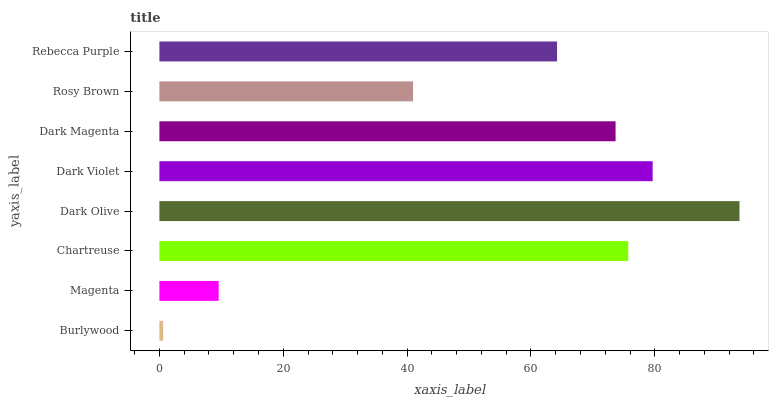Is Burlywood the minimum?
Answer yes or no. Yes. Is Dark Olive the maximum?
Answer yes or no. Yes. Is Magenta the minimum?
Answer yes or no. No. Is Magenta the maximum?
Answer yes or no. No. Is Magenta greater than Burlywood?
Answer yes or no. Yes. Is Burlywood less than Magenta?
Answer yes or no. Yes. Is Burlywood greater than Magenta?
Answer yes or no. No. Is Magenta less than Burlywood?
Answer yes or no. No. Is Dark Magenta the high median?
Answer yes or no. Yes. Is Rebecca Purple the low median?
Answer yes or no. Yes. Is Dark Olive the high median?
Answer yes or no. No. Is Chartreuse the low median?
Answer yes or no. No. 